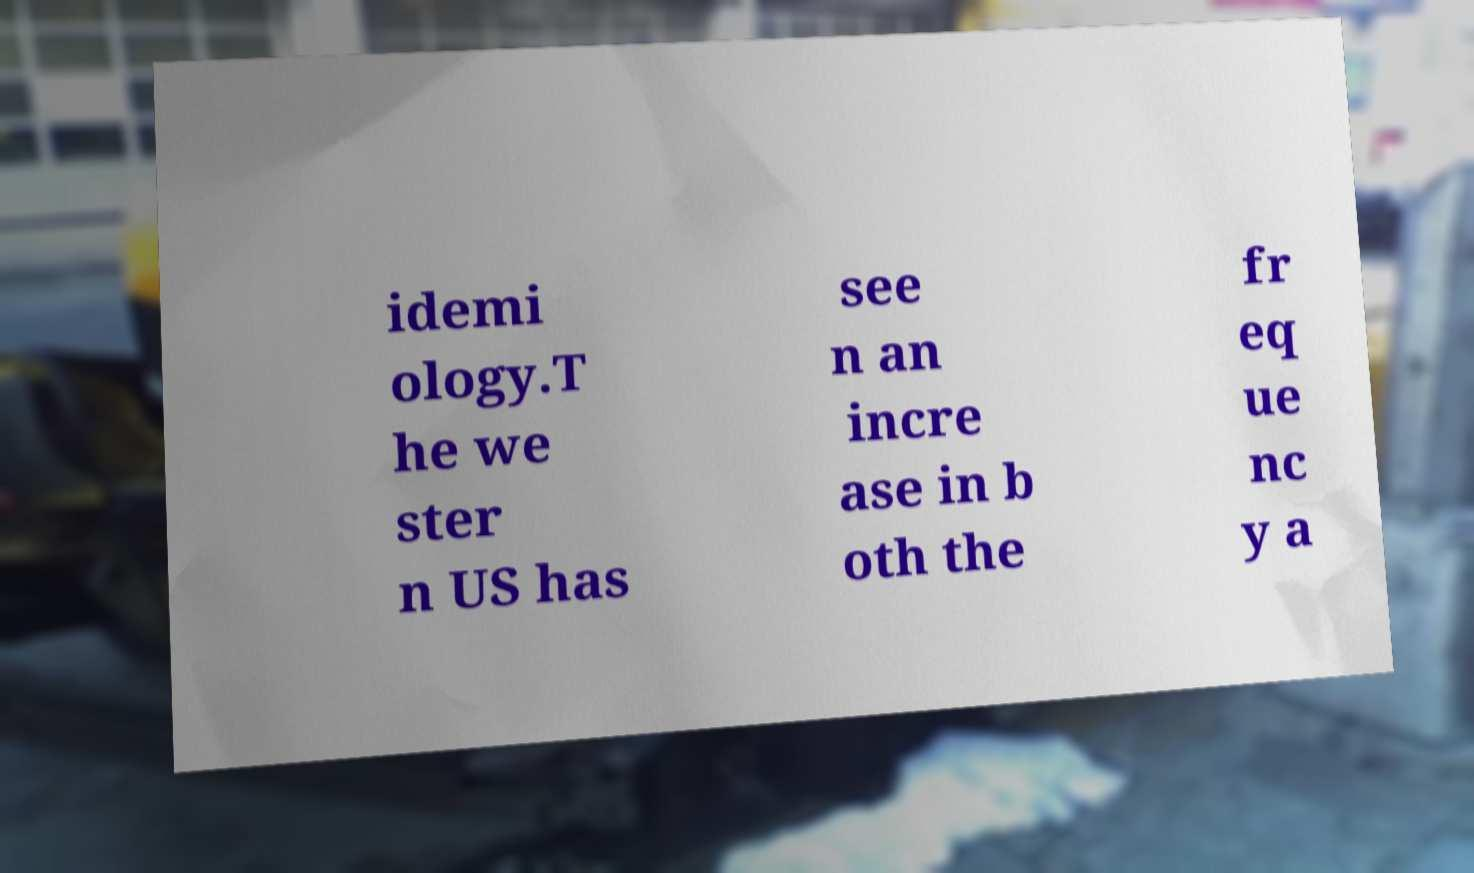Could you assist in decoding the text presented in this image and type it out clearly? idemi ology.T he we ster n US has see n an incre ase in b oth the fr eq ue nc y a 